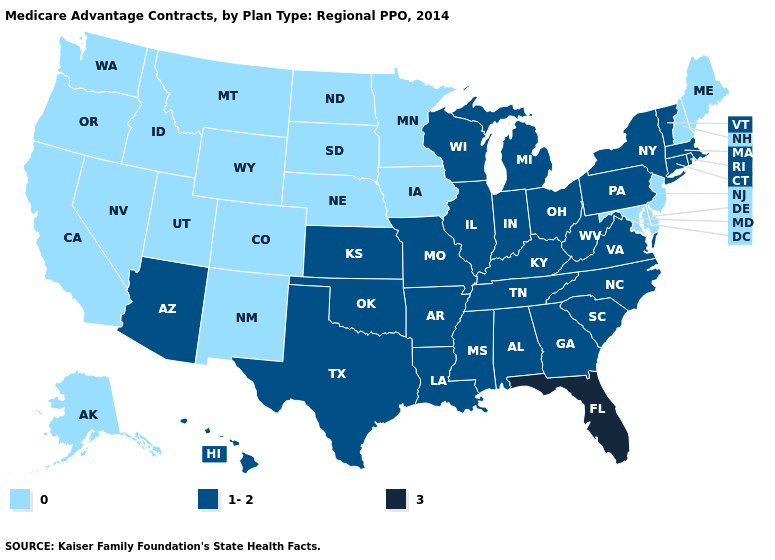Among the states that border North Carolina , which have the highest value?
Be succinct. Georgia, South Carolina, Tennessee, Virginia. Is the legend a continuous bar?
Concise answer only. No. What is the lowest value in the USA?
Write a very short answer. 0. What is the value of Idaho?
Concise answer only. 0. What is the highest value in states that border Maine?
Give a very brief answer. 0. What is the value of South Carolina?
Give a very brief answer. 1-2. Is the legend a continuous bar?
Be succinct. No. Does the map have missing data?
Give a very brief answer. No. What is the value of Arkansas?
Keep it brief. 1-2. What is the highest value in the USA?
Quick response, please. 3. Is the legend a continuous bar?
Short answer required. No. What is the lowest value in the USA?
Short answer required. 0. Which states have the highest value in the USA?
Be succinct. Florida. Which states have the highest value in the USA?
Write a very short answer. Florida. Name the states that have a value in the range 0?
Quick response, please. Alaska, California, Colorado, Delaware, Iowa, Idaho, Maryland, Maine, Minnesota, Montana, North Dakota, Nebraska, New Hampshire, New Jersey, New Mexico, Nevada, Oregon, South Dakota, Utah, Washington, Wyoming. 